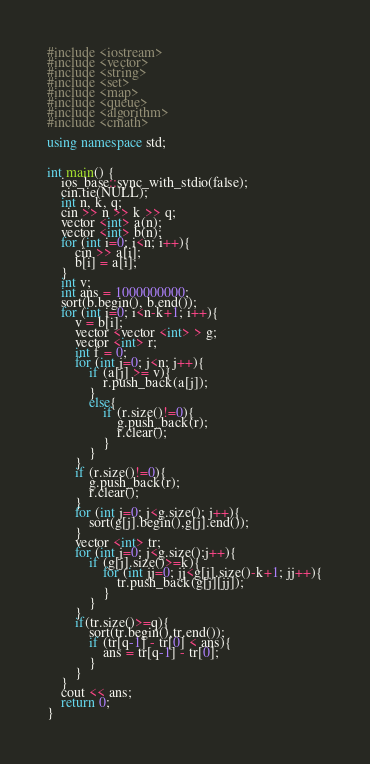Convert code to text. <code><loc_0><loc_0><loc_500><loc_500><_C++_>#include <iostream>
#include <vector>
#include <string>
#include <set>
#include <map>
#include <queue>
#include <algorithm>
#include <cmath>

using namespace std;


int main() {
    ios_base::sync_with_stdio(false);
    cin.tie(NULL);
    int n, k, q;
    cin >> n >> k >> q;
    vector <int> a(n);
    vector <int> b(n);
    for (int i=0; i<n; i++){
        cin >> a[i];
        b[i] = a[i];
    }
    int v;
    int ans = 1000000000;
    sort(b.begin(), b.end());
    for (int i=0; i<n-k+1; i++){
        v = b[i];
        vector <vector <int> > g;
        vector <int> r;
        int f = 0;
        for (int j=0; j<n; j++){
            if (a[j] >= v){
                r.push_back(a[j]);
            }
            else{
                if (r.size()!=0){
                    g.push_back(r);
                    r.clear();
                }
            }
        }
        if (r.size()!=0){
            g.push_back(r);
            r.clear();
        }
        for (int j=0; j<g.size(); j++){
            sort(g[j].begin(),g[j].end());
        }
        vector <int> tr;
        for (int j=0; j<g.size();j++){
            if (g[j].size()>=k){
                for (int jj=0; jj<g[j].size()-k+1; jj++){
                    tr.push_back(g[j][jj]);
                }
            }
        }
        if(tr.size()>=q){
            sort(tr.begin(),tr.end());
            if (tr[q-1] - tr[0] < ans){
                ans = tr[q-1] - tr[0];
            }
        }
    }
    cout << ans;
    return 0;
}</code> 